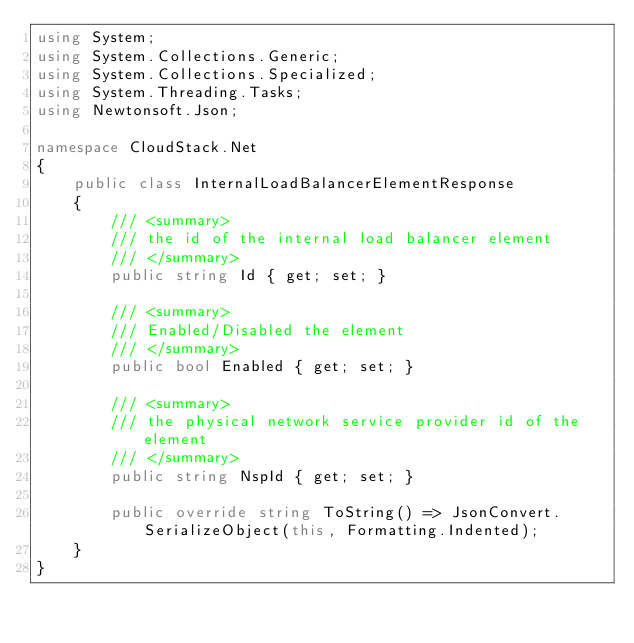Convert code to text. <code><loc_0><loc_0><loc_500><loc_500><_C#_>using System;
using System.Collections.Generic;
using System.Collections.Specialized;
using System.Threading.Tasks;
using Newtonsoft.Json;

namespace CloudStack.Net
{
    public class InternalLoadBalancerElementResponse
    {
        /// <summary>
        /// the id of the internal load balancer element
        /// </summary>
        public string Id { get; set; }

        /// <summary>
        /// Enabled/Disabled the element
        /// </summary>
        public bool Enabled { get; set; }

        /// <summary>
        /// the physical network service provider id of the element
        /// </summary>
        public string NspId { get; set; }

        public override string ToString() => JsonConvert.SerializeObject(this, Formatting.Indented);
    }
}
</code> 